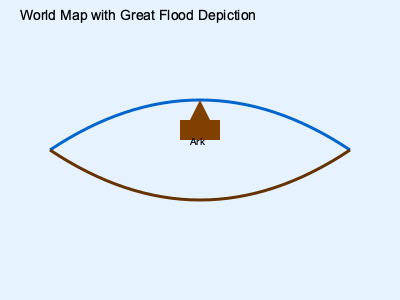In the illustration of the world map depicting the Great Flood, what theological significance can be attributed to the positioning of Noah's Ark at the center of the image, and how does this align with the Biblical narrative? 1. Observe the central positioning of Noah's Ark in the illustration.
2. Recall that in Genesis 6-9, God chose Noah and his family to survive the flood.
3. The central position symbolizes God's focus on Noah and his family as the carriers of His covenant.
4. This placement emphasizes the Ark as the instrument of salvation for humanity and animals.
5. The curved blue line above represents the waters of heaven, while the brown line below represents the waters from the earth, as described in Genesis 7:11.
6. The Ark's position between these lines illustrates God's protection amidst judgment.
7. This depiction reinforces the literal interpretation of the Biblical flood narrative.
8. The simplicity of the world map aligns with the Biblical description, avoiding secular geographical interpretations.
9. The lack of specific landmasses supports a global flood interpretation rather than a localized event.
10. This representation encourages viewers to focus on the theological message rather than historical or geographical details.
Answer: Central placement of the Ark emphasizes God's covenant and salvation plan, reinforcing a literal interpretation of the global flood narrative. 